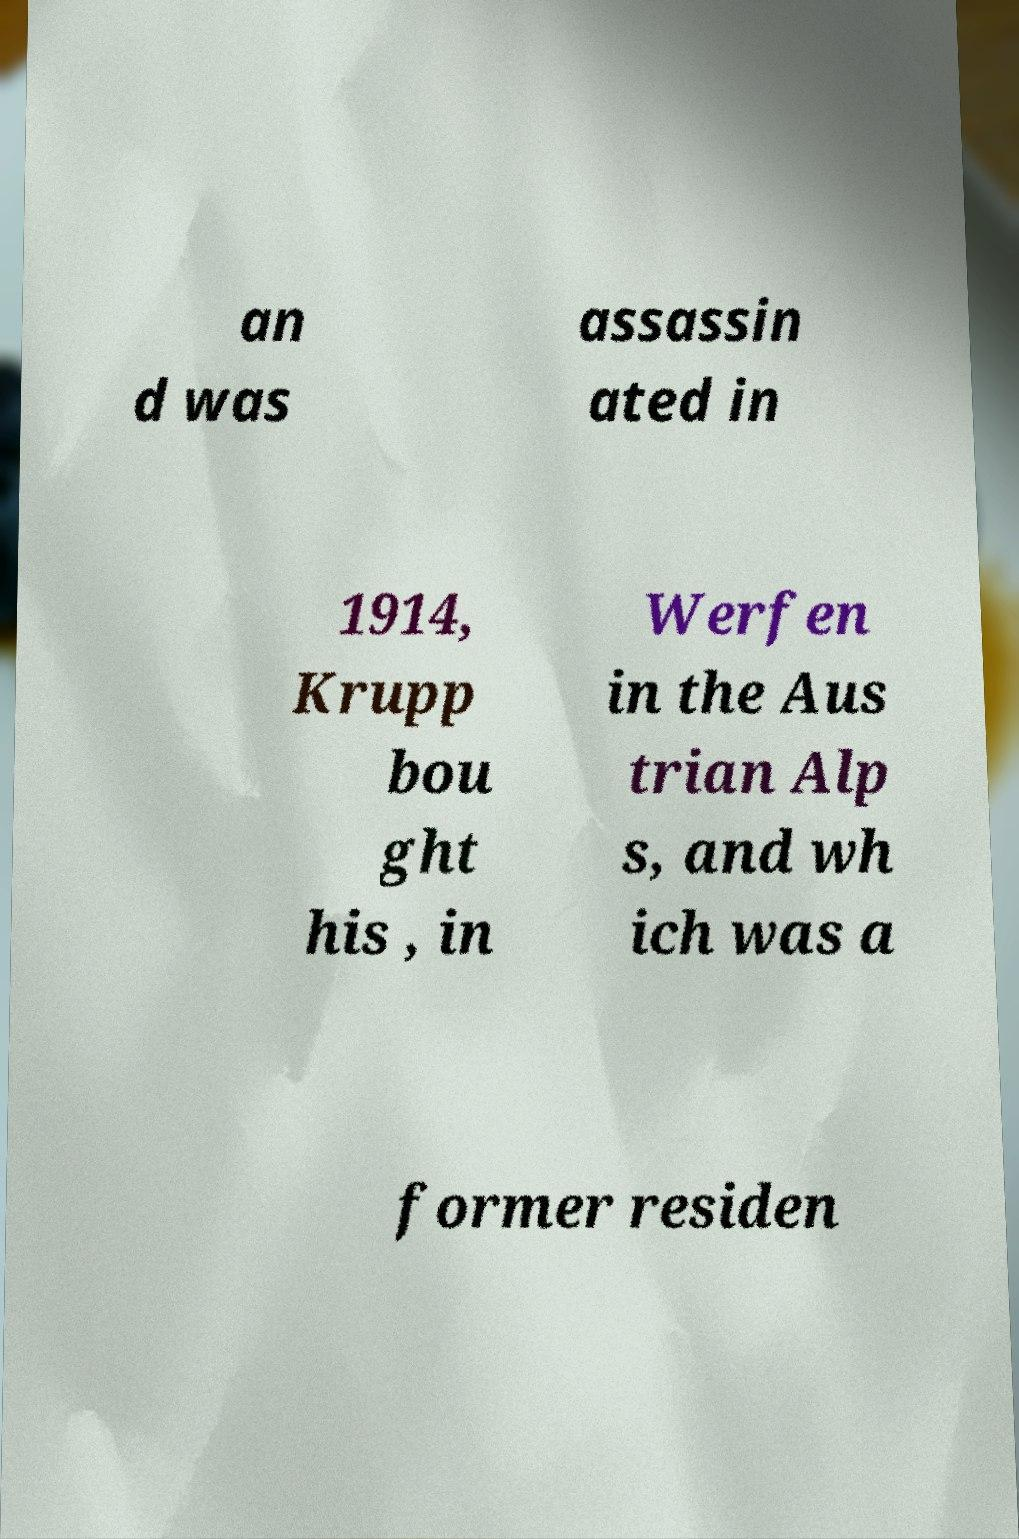Could you extract and type out the text from this image? an d was assassin ated in 1914, Krupp bou ght his , in Werfen in the Aus trian Alp s, and wh ich was a former residen 